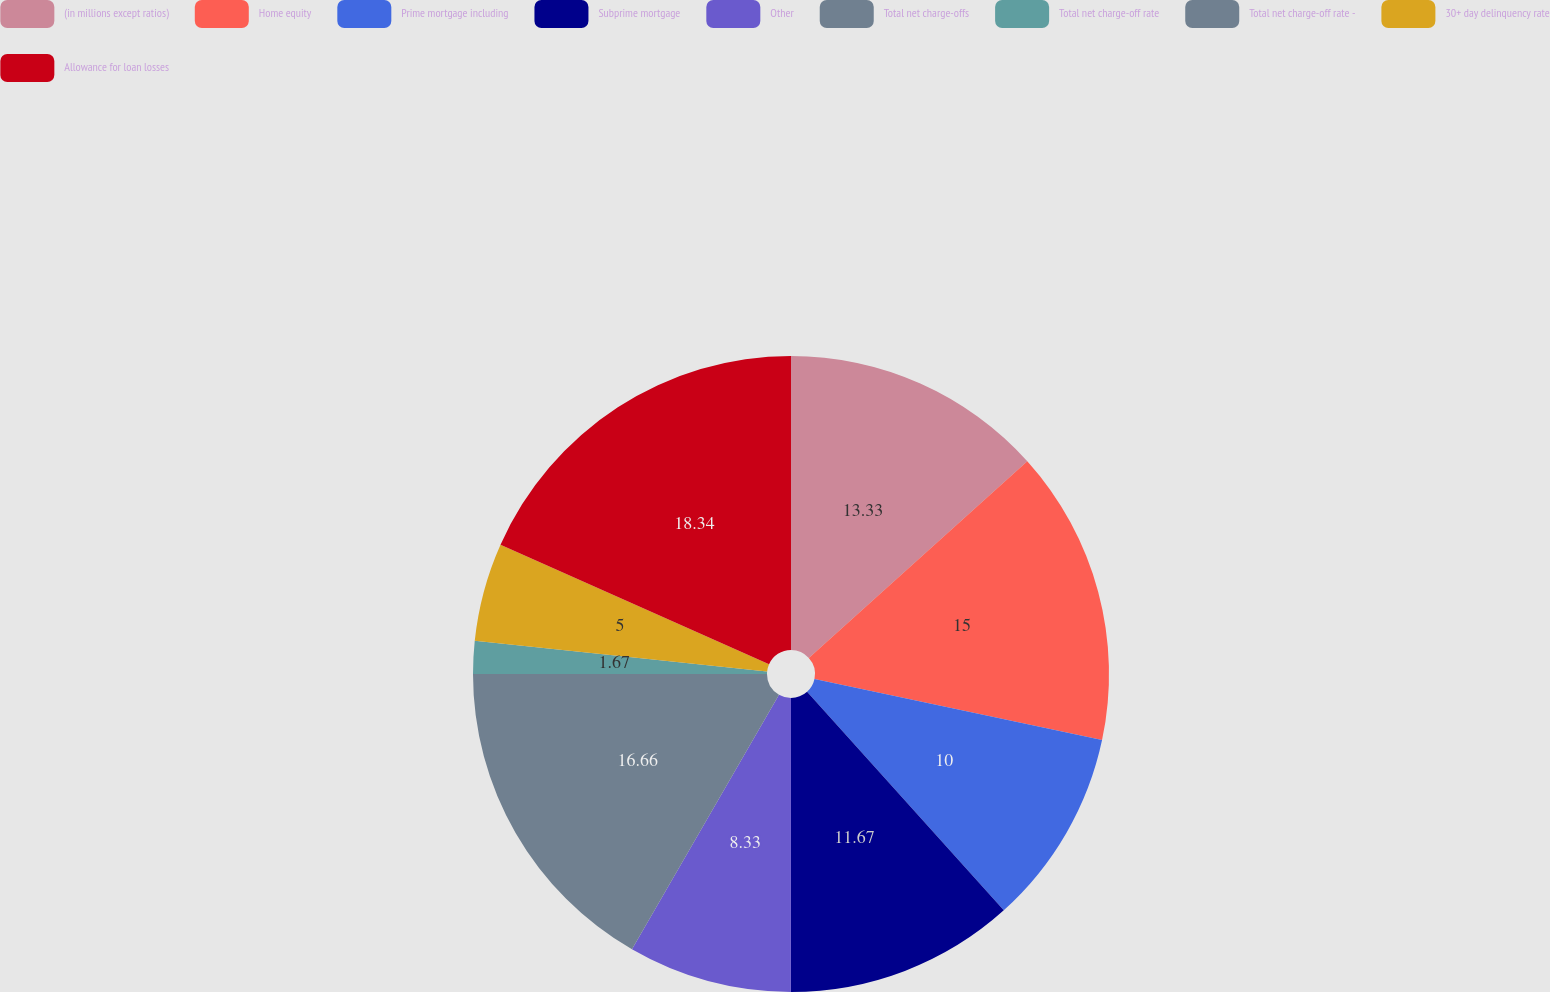Convert chart. <chart><loc_0><loc_0><loc_500><loc_500><pie_chart><fcel>(in millions except ratios)<fcel>Home equity<fcel>Prime mortgage including<fcel>Subprime mortgage<fcel>Other<fcel>Total net charge-offs<fcel>Total net charge-off rate<fcel>Total net charge-off rate -<fcel>30+ day delinquency rate<fcel>Allowance for loan losses<nl><fcel>13.33%<fcel>15.0%<fcel>10.0%<fcel>11.67%<fcel>8.33%<fcel>16.66%<fcel>1.67%<fcel>0.0%<fcel>5.0%<fcel>18.33%<nl></chart> 